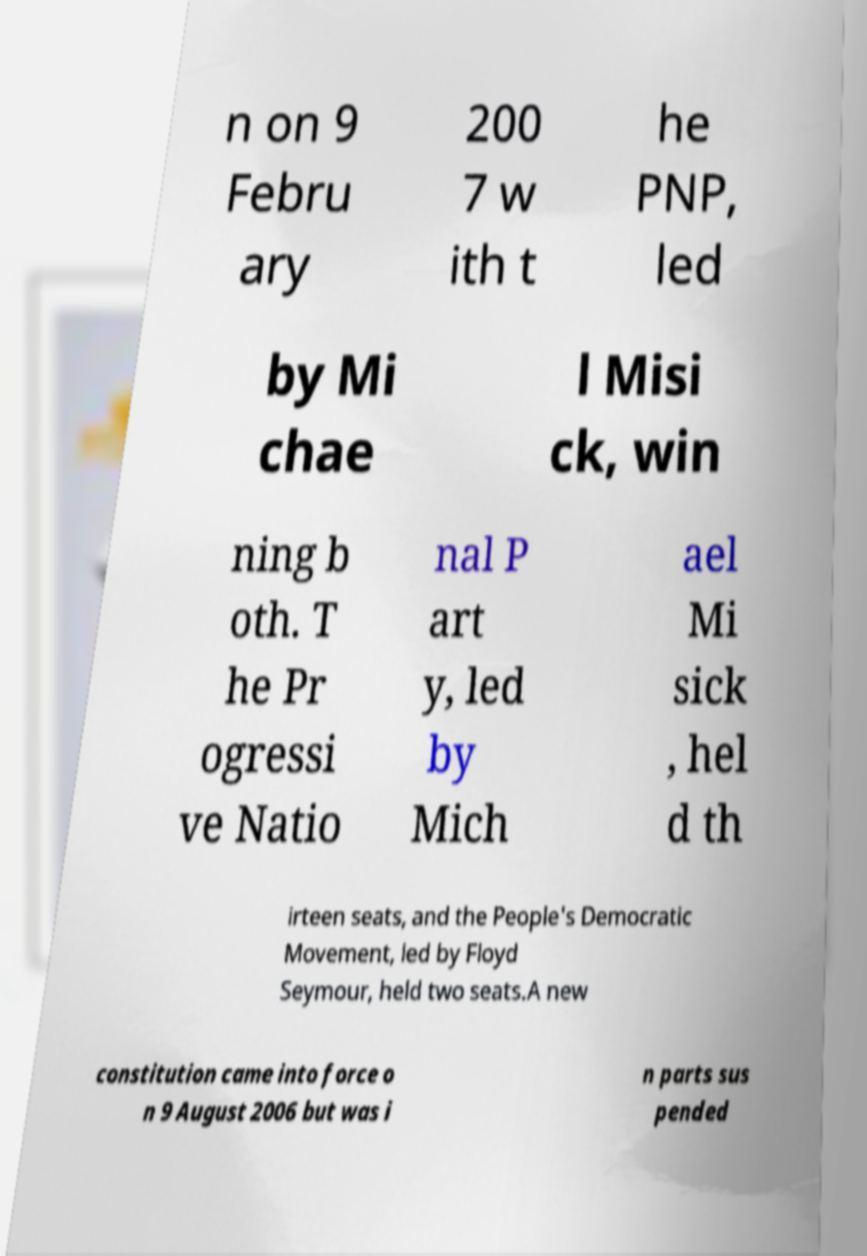I need the written content from this picture converted into text. Can you do that? n on 9 Febru ary 200 7 w ith t he PNP, led by Mi chae l Misi ck, win ning b oth. T he Pr ogressi ve Natio nal P art y, led by Mich ael Mi sick , hel d th irteen seats, and the People's Democratic Movement, led by Floyd Seymour, held two seats.A new constitution came into force o n 9 August 2006 but was i n parts sus pended 